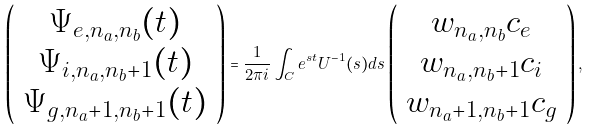Convert formula to latex. <formula><loc_0><loc_0><loc_500><loc_500>\left ( \begin{array} { c c c c } \Psi _ { e , n _ { a } , n _ { b } } ( t ) \\ \Psi _ { i , n _ { a } , n _ { b } + 1 } ( t ) \\ \Psi _ { g , n _ { a } + 1 , n _ { b } + 1 } ( t ) \end{array} \right ) = \frac { 1 } { 2 \pi i } \int _ { C } e ^ { s t } U ^ { - 1 } ( s ) d s \left ( \begin{array} { c c c c } w _ { n _ { a } , n _ { b } } c _ { e } \\ w _ { n _ { a } , n _ { b } + 1 } c _ { i } \\ w _ { n _ { a } + 1 , n _ { b } + 1 } c _ { g } \end{array} \right ) ,</formula> 